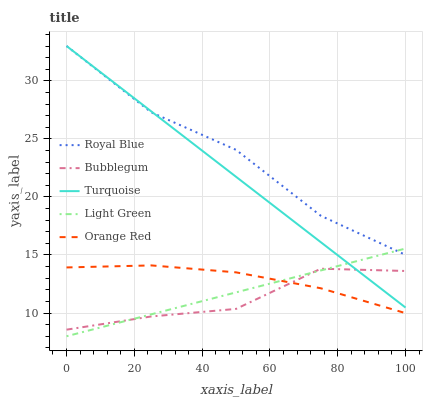Does Bubblegum have the minimum area under the curve?
Answer yes or no. Yes. Does Royal Blue have the maximum area under the curve?
Answer yes or no. Yes. Does Turquoise have the minimum area under the curve?
Answer yes or no. No. Does Turquoise have the maximum area under the curve?
Answer yes or no. No. Is Turquoise the smoothest?
Answer yes or no. Yes. Is Royal Blue the roughest?
Answer yes or no. Yes. Is Light Green the smoothest?
Answer yes or no. No. Is Light Green the roughest?
Answer yes or no. No. Does Light Green have the lowest value?
Answer yes or no. Yes. Does Turquoise have the lowest value?
Answer yes or no. No. Does Turquoise have the highest value?
Answer yes or no. Yes. Does Light Green have the highest value?
Answer yes or no. No. Is Bubblegum less than Royal Blue?
Answer yes or no. Yes. Is Turquoise greater than Orange Red?
Answer yes or no. Yes. Does Royal Blue intersect Turquoise?
Answer yes or no. Yes. Is Royal Blue less than Turquoise?
Answer yes or no. No. Is Royal Blue greater than Turquoise?
Answer yes or no. No. Does Bubblegum intersect Royal Blue?
Answer yes or no. No. 